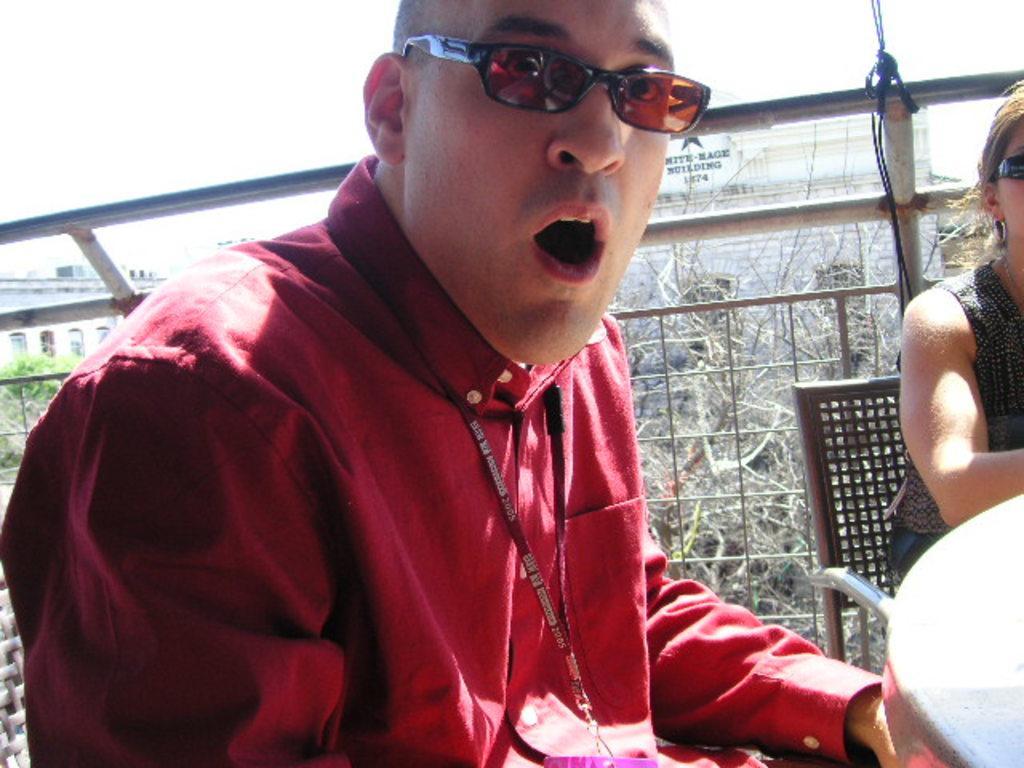Please provide a concise description of this image. In this image there is a man sitting in the chair by opening his mouth. He has a black specks. On the right side there is a lady sitting in the chair in front of the table. In the background there is an iron railing. At the top there is sky. In the background there are buildings and trees. 